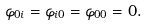Convert formula to latex. <formula><loc_0><loc_0><loc_500><loc_500>\varphi _ { 0 i } = \varphi _ { i 0 } = \varphi _ { 0 0 } = 0 .</formula> 